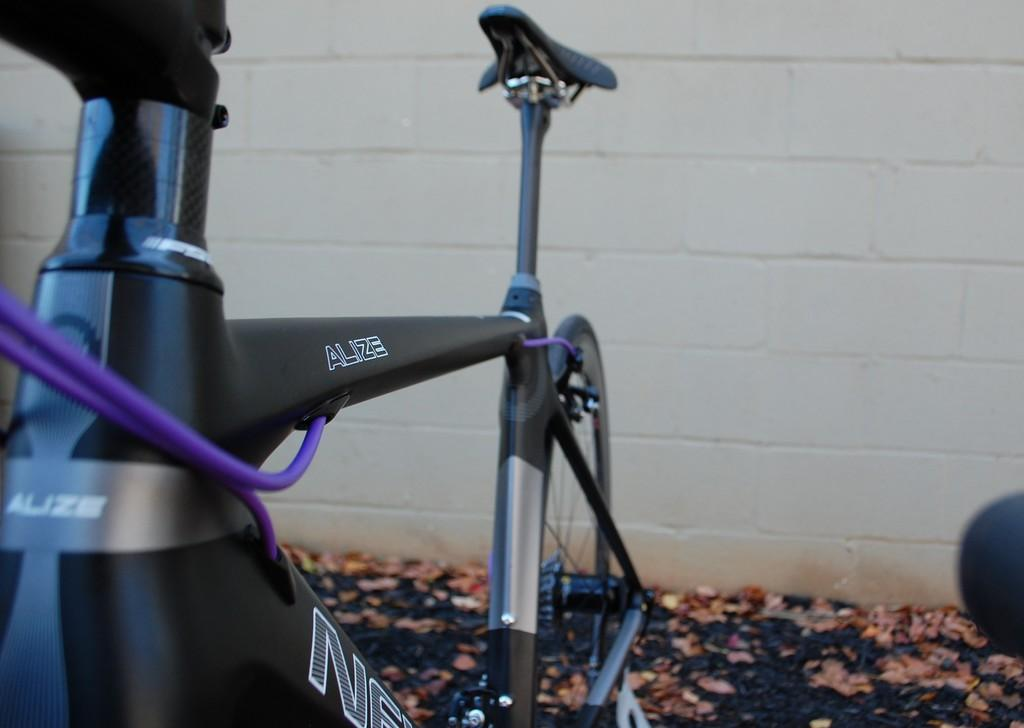What is the main object in the image? There is a bicycle in the image. How is the bicycle positioned in the image? The bicycle is parked on the ground. What type of natural debris can be seen in the image? There are dried leaves in the image. What is visible at the top of the image? There is a wall visible at the top of the image. How many passengers are riding the swing in the image? There is no swing present in the image, so there are no passengers riding it. 